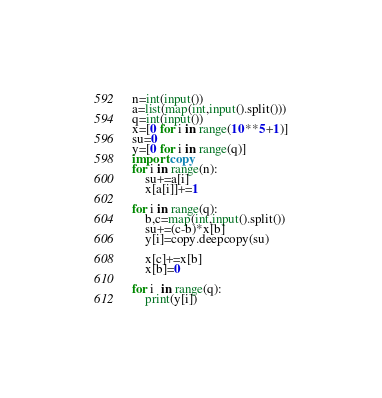Convert code to text. <code><loc_0><loc_0><loc_500><loc_500><_Python_>n=int(input())
a=list(map(int,input().split()))
q=int(input())
x=[0 for i in range(10**5+1)]
su=0
y=[0 for i in range(q)]
import copy
for i in range(n):
    su+=a[i]
    x[a[i]]+=1

for i in range(q):
    b,c=map(int,input().split())
    su+=(c-b)*x[b]
    y[i]=copy.deepcopy(su)
    
    x[c]+=x[b]
    x[b]=0
    
for i  in range(q):
    print(y[i])</code> 